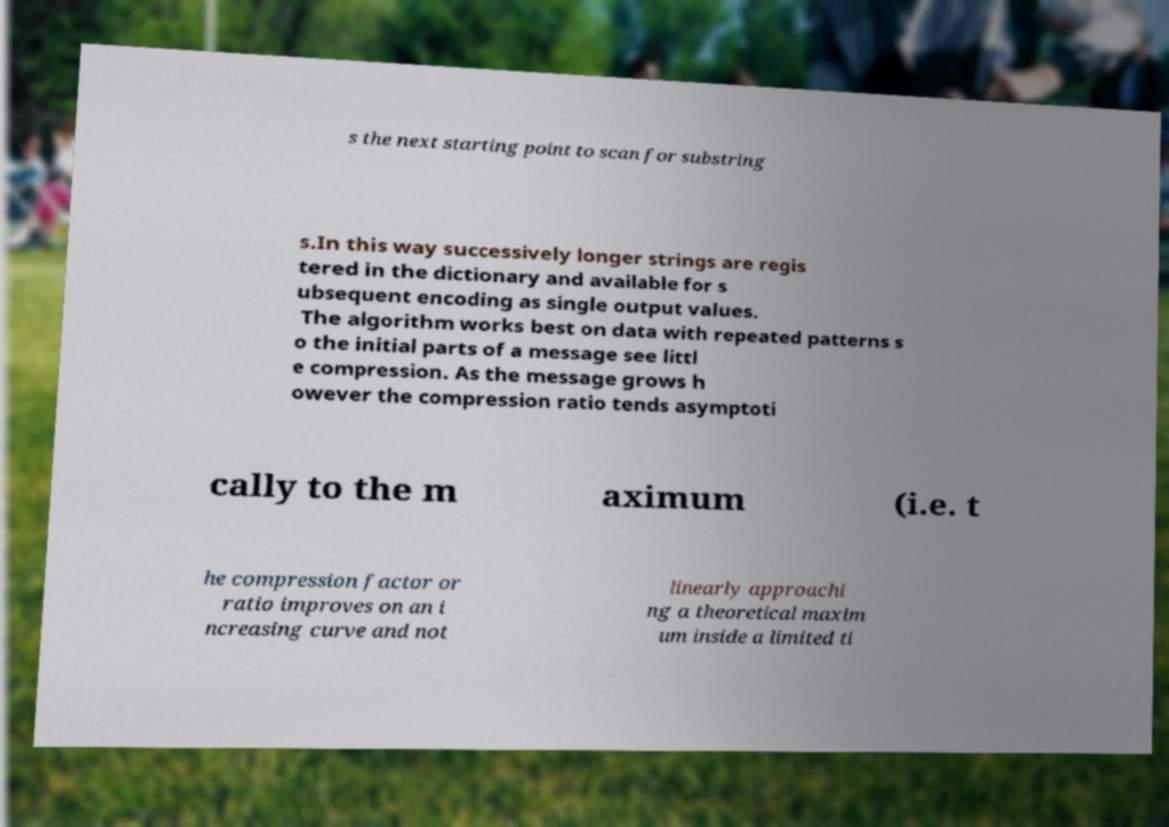Can you read and provide the text displayed in the image?This photo seems to have some interesting text. Can you extract and type it out for me? s the next starting point to scan for substring s.In this way successively longer strings are regis tered in the dictionary and available for s ubsequent encoding as single output values. The algorithm works best on data with repeated patterns s o the initial parts of a message see littl e compression. As the message grows h owever the compression ratio tends asymptoti cally to the m aximum (i.e. t he compression factor or ratio improves on an i ncreasing curve and not linearly approachi ng a theoretical maxim um inside a limited ti 